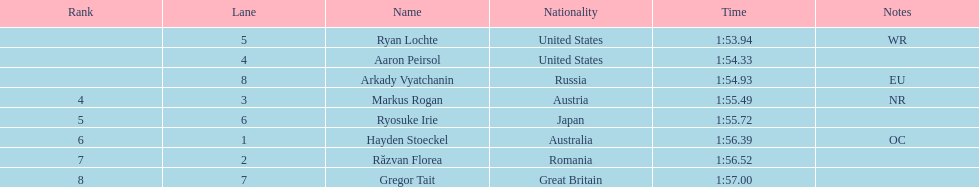How many swimmers finished in less than 1:55? 3. Can you give me this table as a dict? {'header': ['Rank', 'Lane', 'Name', 'Nationality', 'Time', 'Notes'], 'rows': [['', '5', 'Ryan Lochte', 'United States', '1:53.94', 'WR'], ['', '4', 'Aaron Peirsol', 'United States', '1:54.33', ''], ['', '8', 'Arkady Vyatchanin', 'Russia', '1:54.93', 'EU'], ['4', '3', 'Markus Rogan', 'Austria', '1:55.49', 'NR'], ['5', '6', 'Ryosuke Irie', 'Japan', '1:55.72', ''], ['6', '1', 'Hayden Stoeckel', 'Australia', '1:56.39', 'OC'], ['7', '2', 'Răzvan Florea', 'Romania', '1:56.52', ''], ['8', '7', 'Gregor Tait', 'Great Britain', '1:57.00', '']]} 